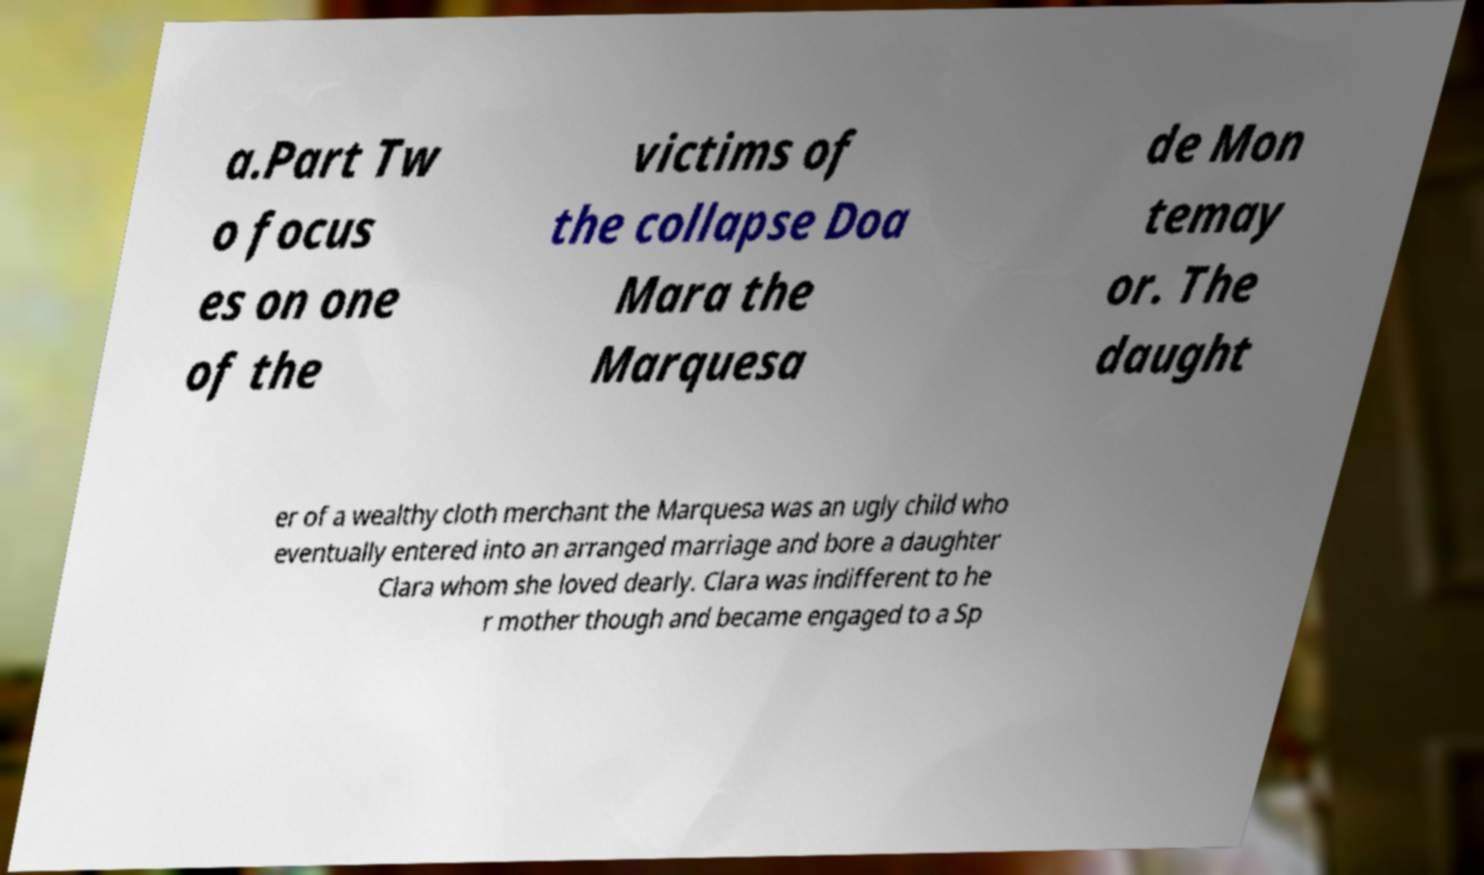For documentation purposes, I need the text within this image transcribed. Could you provide that? a.Part Tw o focus es on one of the victims of the collapse Doa Mara the Marquesa de Mon temay or. The daught er of a wealthy cloth merchant the Marquesa was an ugly child who eventually entered into an arranged marriage and bore a daughter Clara whom she loved dearly. Clara was indifferent to he r mother though and became engaged to a Sp 